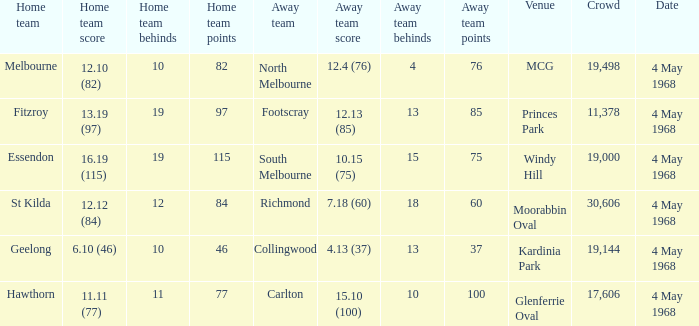How big was the crowd of the team that scored 4.13 (37)? 19144.0. 